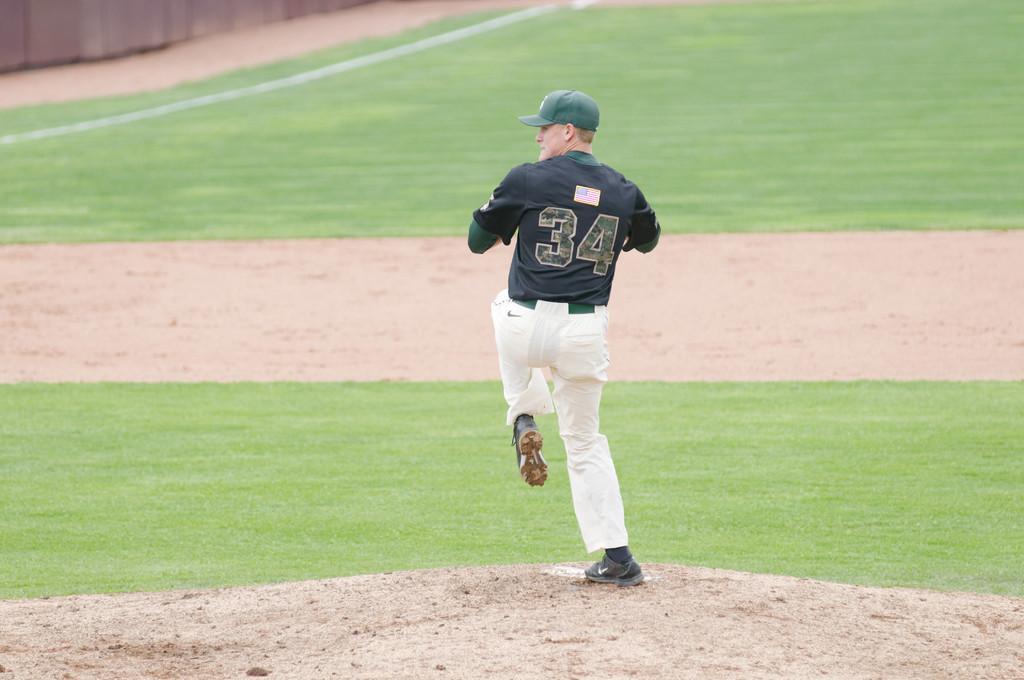Could you give a brief overview of what you see in this image? In this image we can see a person wearing dress, shoes and green cap is standing on the ground. 